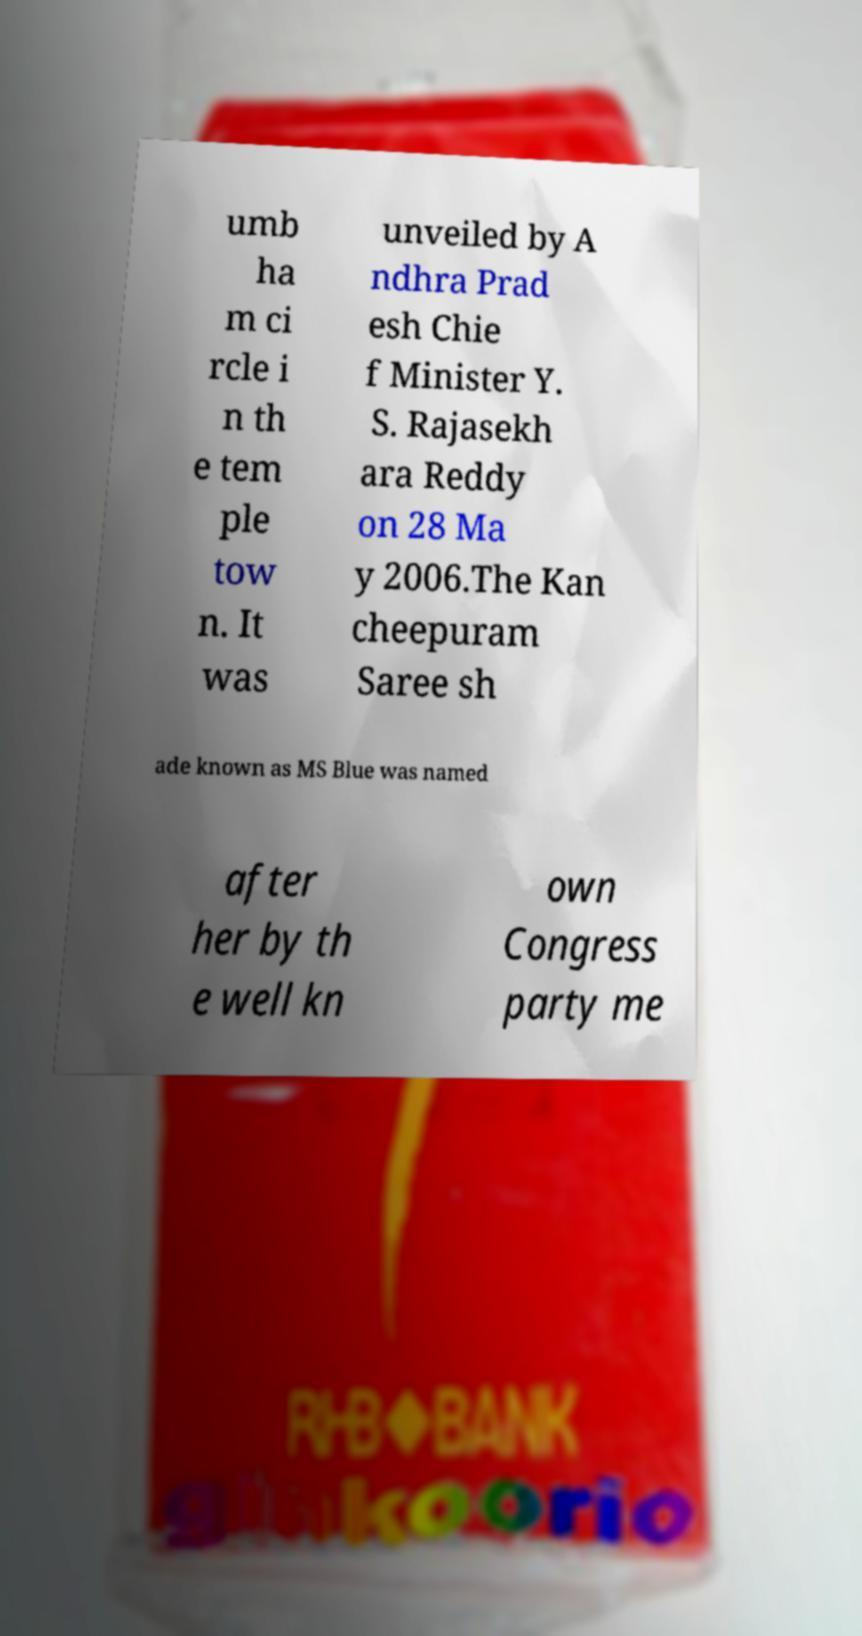There's text embedded in this image that I need extracted. Can you transcribe it verbatim? umb ha m ci rcle i n th e tem ple tow n. It was unveiled by A ndhra Prad esh Chie f Minister Y. S. Rajasekh ara Reddy on 28 Ma y 2006.The Kan cheepuram Saree sh ade known as MS Blue was named after her by th e well kn own Congress party me 